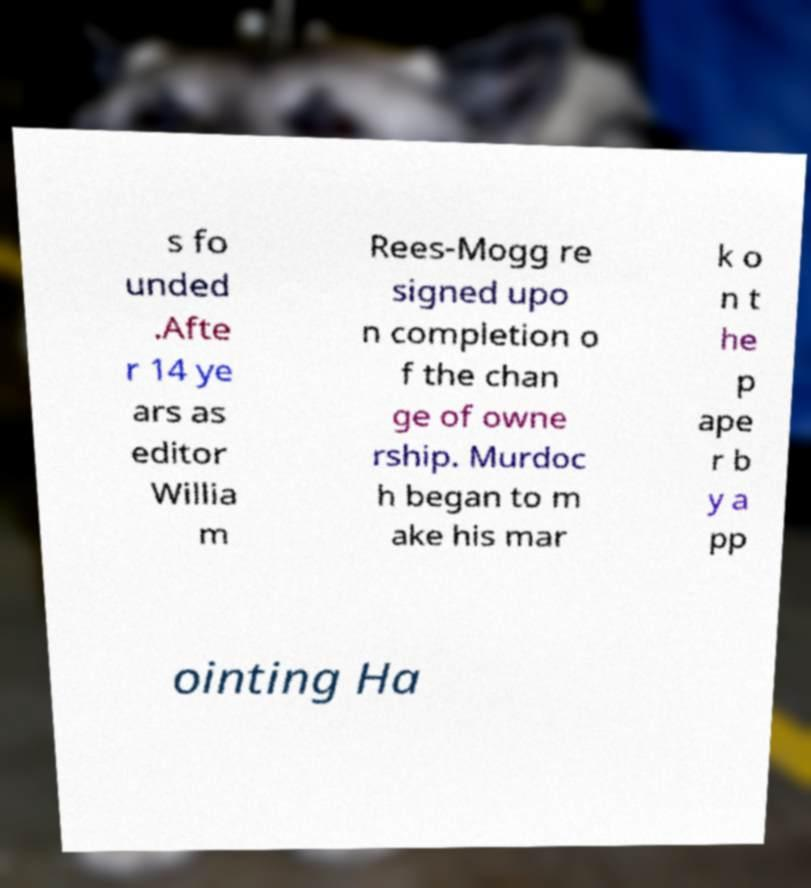Please read and relay the text visible in this image. What does it say? s fo unded .Afte r 14 ye ars as editor Willia m Rees-Mogg re signed upo n completion o f the chan ge of owne rship. Murdoc h began to m ake his mar k o n t he p ape r b y a pp ointing Ha 